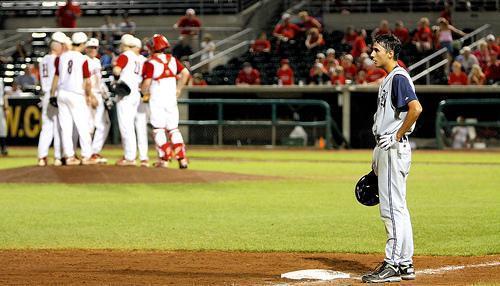How many players are wearing the shirt with blue sleeves?
Give a very brief answer. 1. 